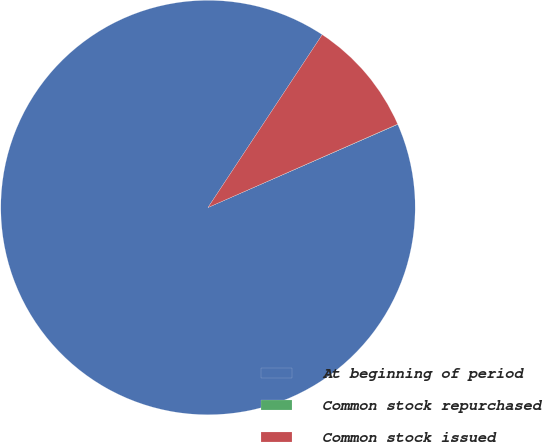Convert chart. <chart><loc_0><loc_0><loc_500><loc_500><pie_chart><fcel>At beginning of period<fcel>Common stock repurchased<fcel>Common stock issued<nl><fcel>90.87%<fcel>0.02%<fcel>9.11%<nl></chart> 